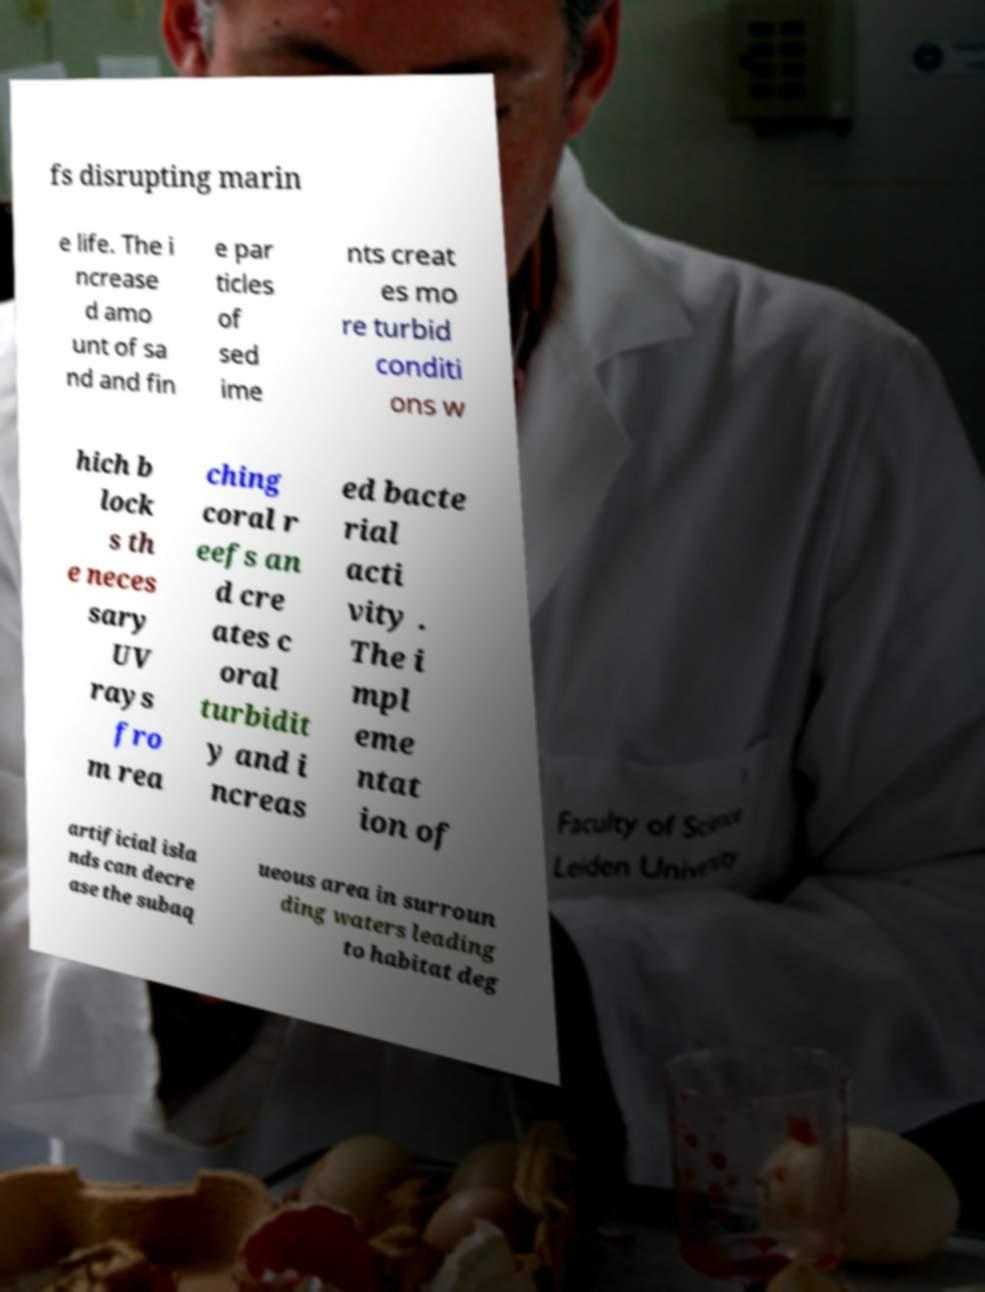Could you extract and type out the text from this image? fs disrupting marin e life. The i ncrease d amo unt of sa nd and fin e par ticles of sed ime nts creat es mo re turbid conditi ons w hich b lock s th e neces sary UV rays fro m rea ching coral r eefs an d cre ates c oral turbidit y and i ncreas ed bacte rial acti vity . The i mpl eme ntat ion of artificial isla nds can decre ase the subaq ueous area in surroun ding waters leading to habitat deg 